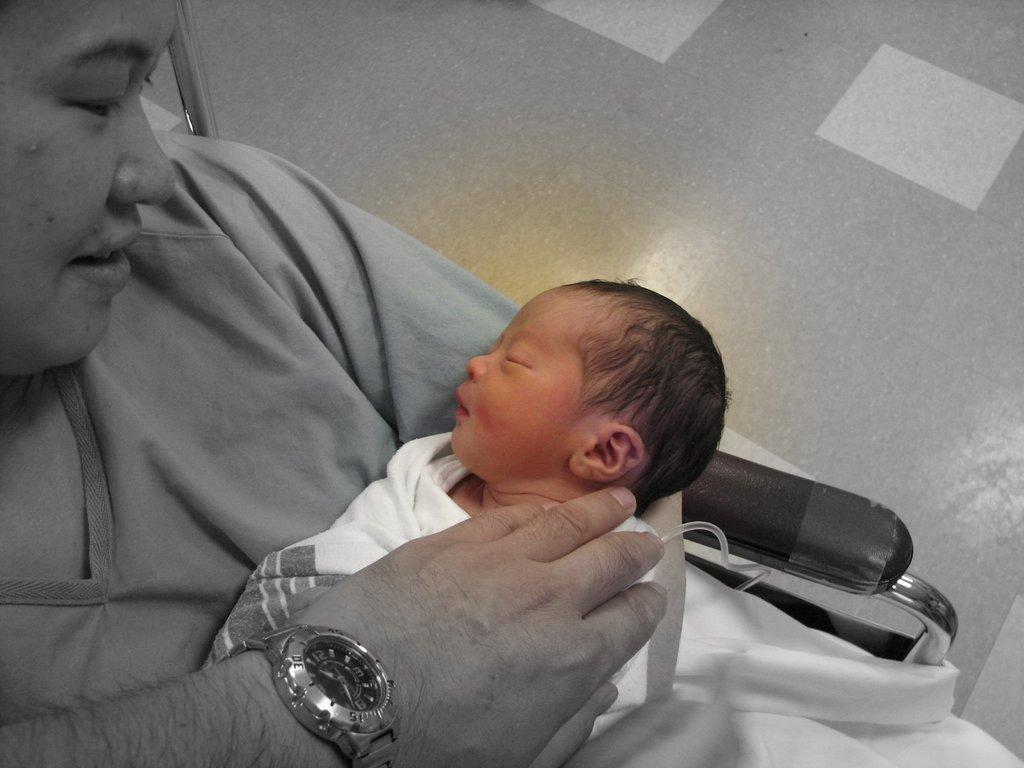Who is the main subject in the image? There is a woman in the image. What is the woman doing in the image? The woman is sitting on a chair and holding a baby. Can you describe the baby in the image? The baby has a person's hand with a watch on it. What is the material of the rod visible in the image? The rod visible in the image is made of steel. What is the surface beneath the woman and baby? There is a floor in the image. What type of muscle is being exercised by the woman in the image? There is no indication of exercise or muscle activity in the image; the woman is simply sitting and holding a baby. 